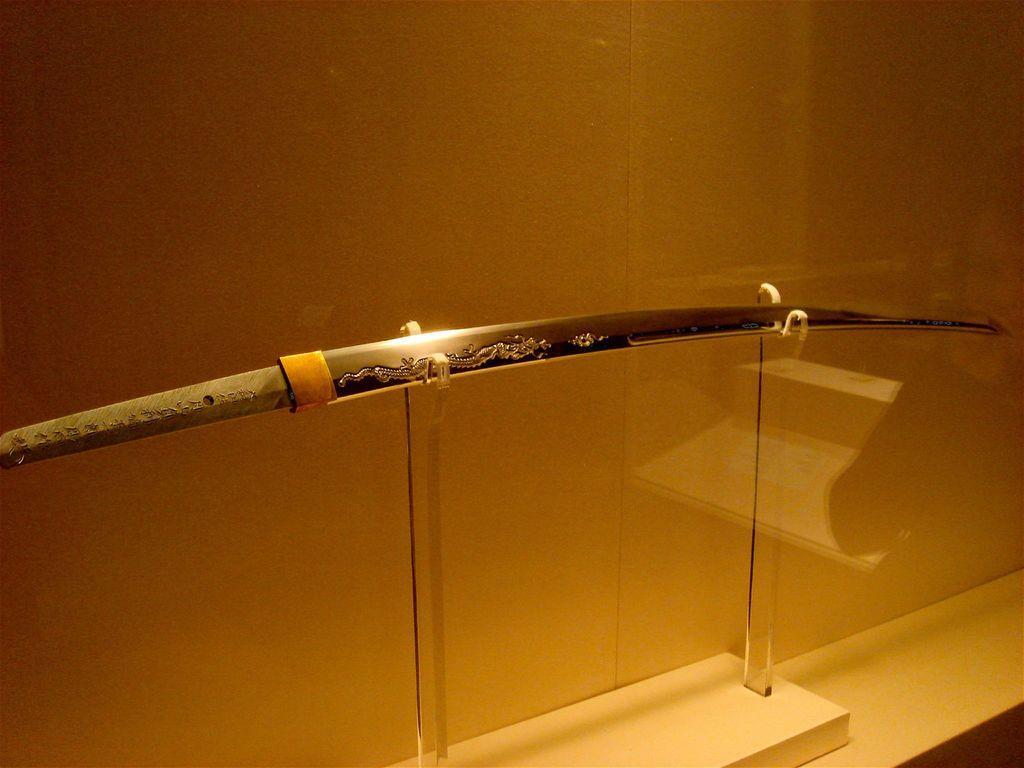Can you describe this image briefly? In the image we can see there is a sword kept on the stand and behind there is a wall. 